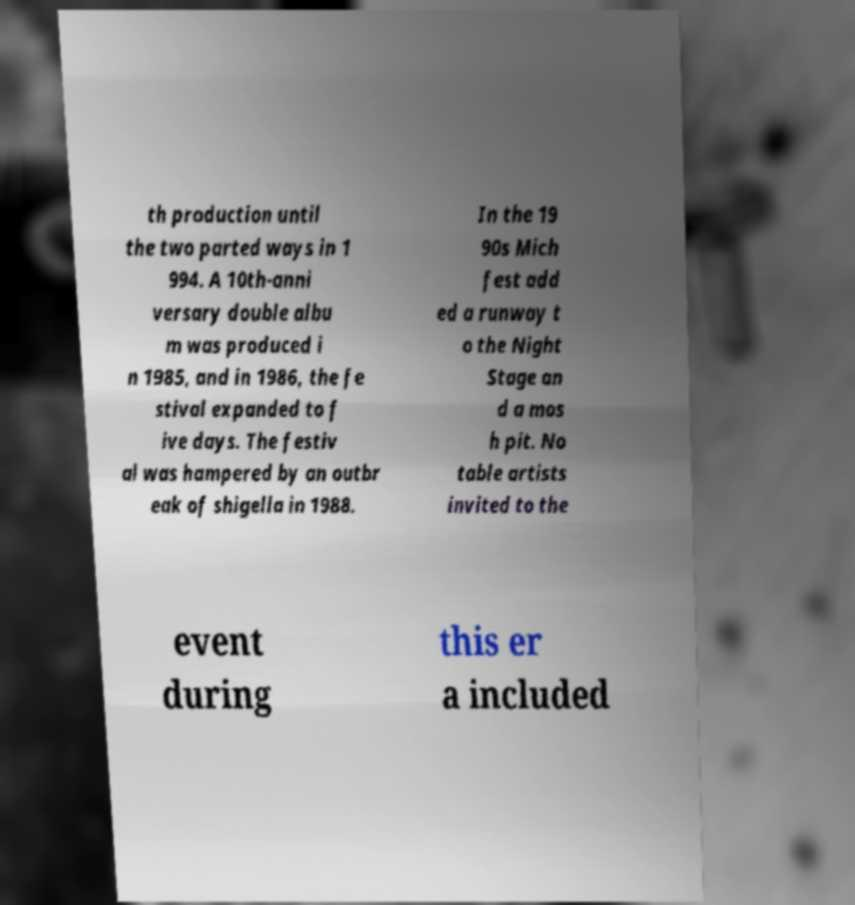For documentation purposes, I need the text within this image transcribed. Could you provide that? th production until the two parted ways in 1 994. A 10th-anni versary double albu m was produced i n 1985, and in 1986, the fe stival expanded to f ive days. The festiv al was hampered by an outbr eak of shigella in 1988. In the 19 90s Mich fest add ed a runway t o the Night Stage an d a mos h pit. No table artists invited to the event during this er a included 